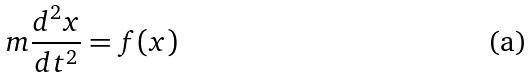<formula> <loc_0><loc_0><loc_500><loc_500>m \frac { d ^ { 2 } x } { d t ^ { 2 } } = f ( x )</formula> 